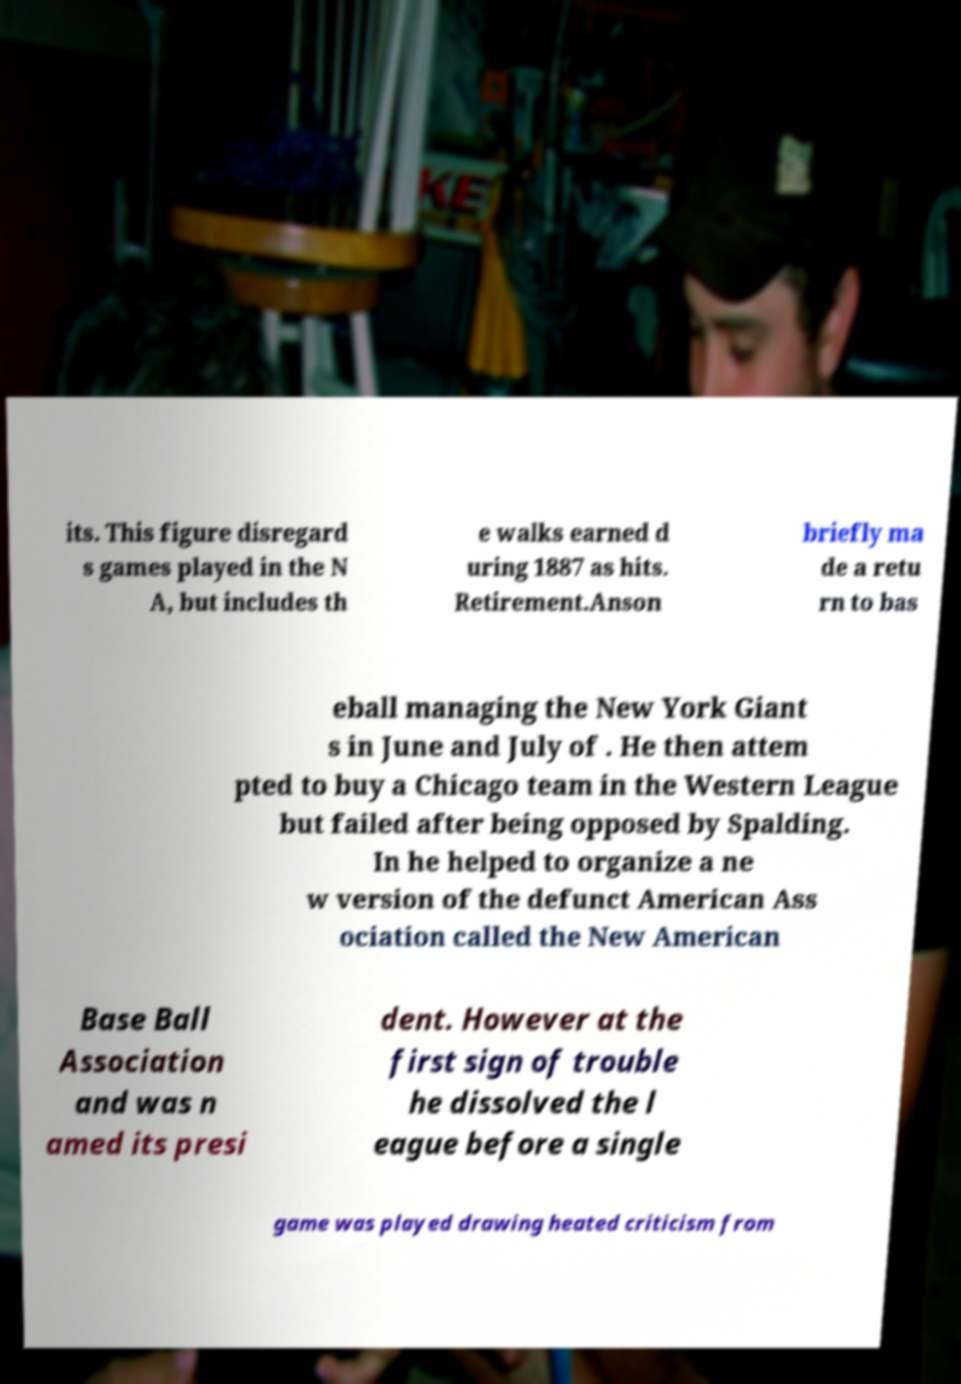Could you extract and type out the text from this image? its. This figure disregard s games played in the N A, but includes th e walks earned d uring 1887 as hits. Retirement.Anson briefly ma de a retu rn to bas eball managing the New York Giant s in June and July of . He then attem pted to buy a Chicago team in the Western League but failed after being opposed by Spalding. In he helped to organize a ne w version of the defunct American Ass ociation called the New American Base Ball Association and was n amed its presi dent. However at the first sign of trouble he dissolved the l eague before a single game was played drawing heated criticism from 